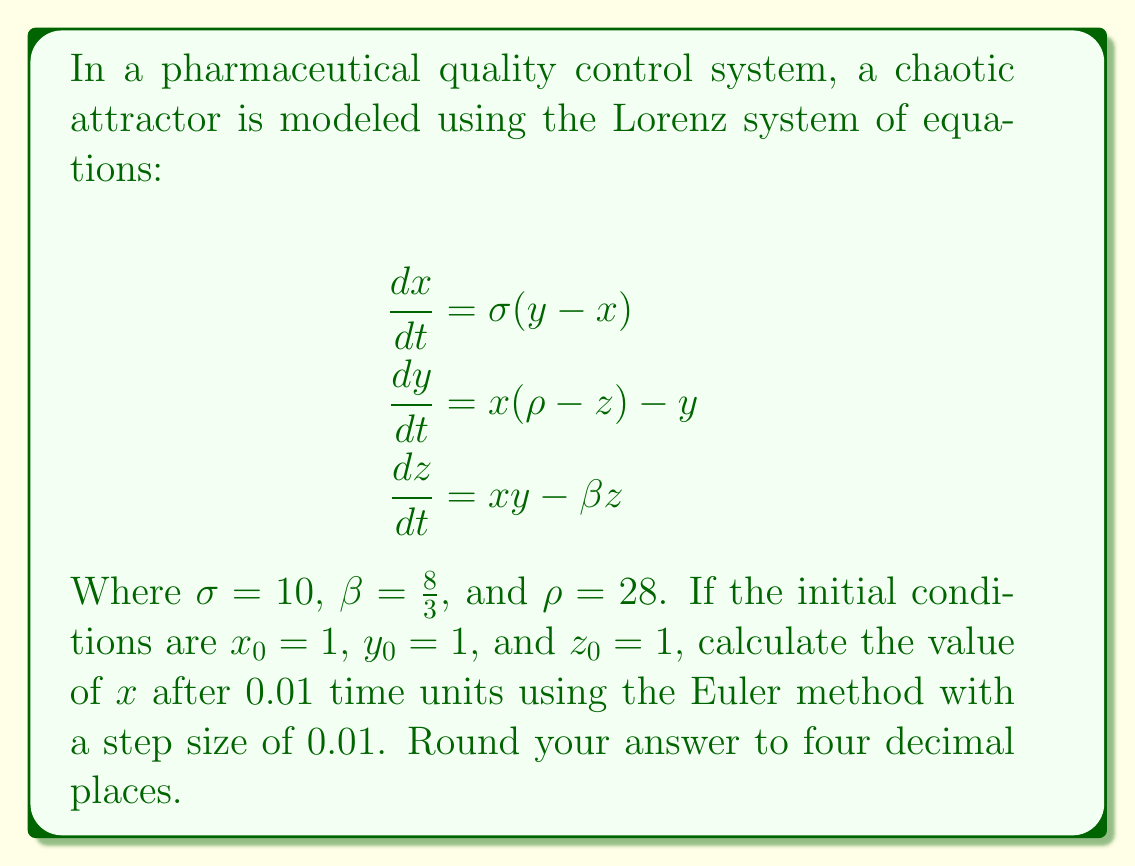Could you help me with this problem? To solve this problem, we'll use the Euler method to approximate the solution of the Lorenz system. The Euler method is given by:

$$x_{n+1} = x_n + h \cdot f(x_n, y_n, z_n)$$
$$y_{n+1} = y_n + h \cdot g(x_n, y_n, z_n)$$
$$z_{n+1} = z_n + h \cdot k(x_n, y_n, z_n)$$

Where $h$ is the step size, and $f$, $g$, and $k$ are the right-hand sides of the Lorenz equations.

Given:
- Initial conditions: $x_0 = 1$, $y_0 = 1$, $z_0 = 1$
- Parameters: $\sigma = 10$, $\beta = \frac{8}{3}$, $\rho = 28$
- Step size: $h = 0.01$
- Time to calculate: $t = 0.01$ (which is one step)

Step 1: Calculate $f(x_0, y_0, z_0)$:
$$f(x_0, y_0, z_0) = \sigma(y_0 - x_0) = 10(1 - 1) = 0$$

Step 2: Calculate $g(x_0, y_0, z_0)$:
$$g(x_0, y_0, z_0) = x_0(\rho - z_0) - y_0 = 1(28 - 1) - 1 = 26$$

Step 3: Calculate $k(x_0, y_0, z_0)$:
$$k(x_0, y_0, z_0) = x_0y_0 - \beta z_0 = 1 \cdot 1 - \frac{8}{3} \cdot 1 = -\frac{5}{3}$$

Step 4: Apply the Euler method to calculate $x_1$:
$$x_1 = x_0 + h \cdot f(x_0, y_0, z_0) = 1 + 0.01 \cdot 0 = 1$$

Step 5: Round the result to four decimal places:
$$x_1 \approx 1.0000$$
Answer: 1.0000 